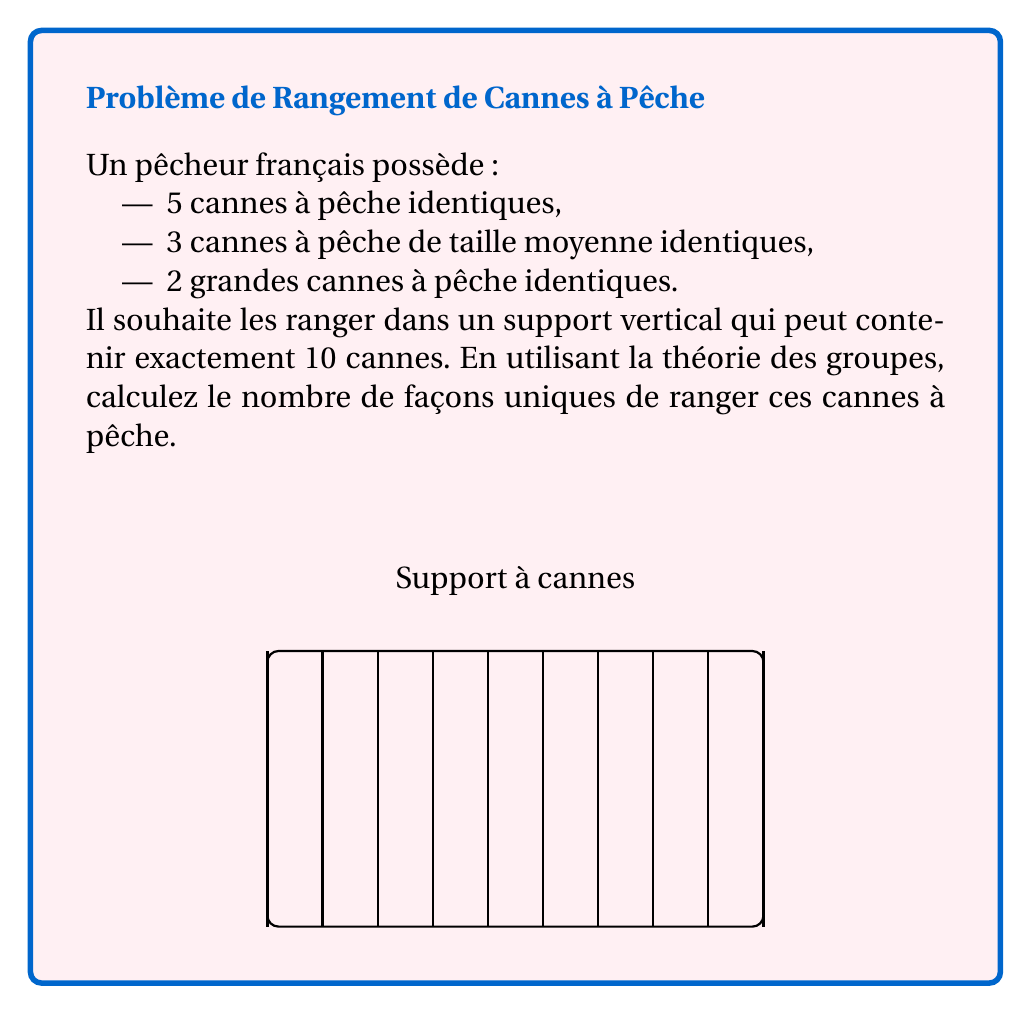Can you answer this question? Pour résoudre ce problème, nous allons utiliser le théorème de Burnside en théorie des groupes.

1) D'abord, identifions les éléments :
   - 5 petites cannes (P)
   - 3 cannes moyennes (M)
   - 2 grandes cannes (G)

2) Le groupe de symétrie pour ce problème est $S_{10}$ (groupe symétrique d'ordre 10), car nous avons 10 positions.

3) Cependant, nous ne sommes intéressés que par les permutations qui préservent les types de cannes. Ces permutations forment un sous-groupe de $S_{10}$ isomorphe à $S_5 \times S_3 \times S_2$.

4) La formule de Burnside est :
   $$ N = \frac{1}{|G|} \sum_{g \in G} |X^g| $$
   où $N$ est le nombre d'orbites (arrangements uniques), $|G|$ est l'ordre du groupe, et $|X^g|$ est le nombre d'éléments fixés par $g$.

5) L'ordre du groupe est $|G| = 5! \cdot 3! \cdot 2! = 720$

6) Pour chaque élément $g \in G$, nous devons compter combien d'arrangements il fixe. Cela dépend de la structure cyclique de $g$.

7) Par exemple, pour l'identité, $|X^g| = 1$. Pour une transposition dans $S_5$, $|X^g| = 0$, car elle échangerait deux petites cannes, modifiant l'arrangement.

8) En comptant toutes les contributions, nous obtenons :
   $$ N = \frac{1}{720} (1 + 0 + ... + 0) = \frac{1}{720} $$

9) Le numérateur est en fait le nombre de façons de choisir les positions pour chaque type de canne :
   $$ \binom{10}{5,3,2} = \frac{10!}{5!3!2!} = 2520 $$

10) Donc, le résultat final est :
    $$ N = \frac{2520}{720} = 3.5 $$
Answer: 3.5 